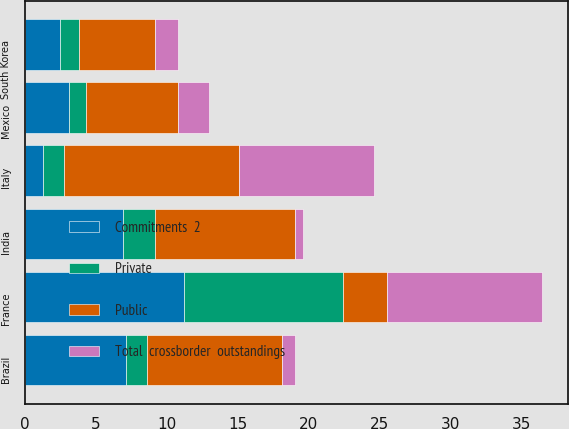Convert chart to OTSL. <chart><loc_0><loc_0><loc_500><loc_500><stacked_bar_chart><ecel><fcel>France<fcel>India<fcel>Mexico<fcel>Brazil<fcel>South Korea<fcel>Italy<nl><fcel>Private<fcel>11.2<fcel>2.3<fcel>1.2<fcel>1.5<fcel>1.3<fcel>1.5<nl><fcel>Total  crossborder  outstandings<fcel>10.9<fcel>0.6<fcel>2.2<fcel>0.9<fcel>1.6<fcel>9.5<nl><fcel>Commitments  2<fcel>11.2<fcel>6.9<fcel>3.1<fcel>7.1<fcel>2.5<fcel>1.3<nl><fcel>Public<fcel>3.1<fcel>9.8<fcel>6.5<fcel>9.5<fcel>5.4<fcel>12.3<nl></chart> 